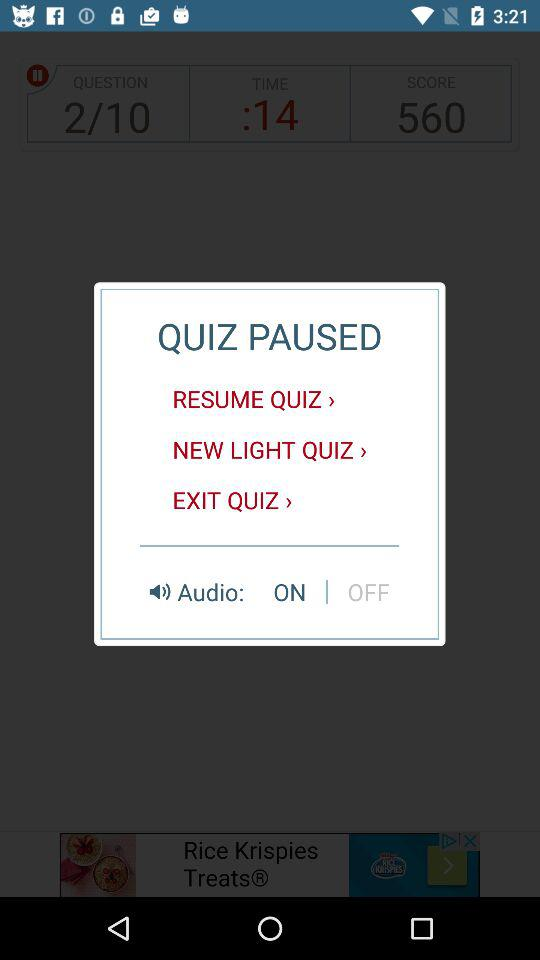What is the total number of scores? The total number of scores is 560. 